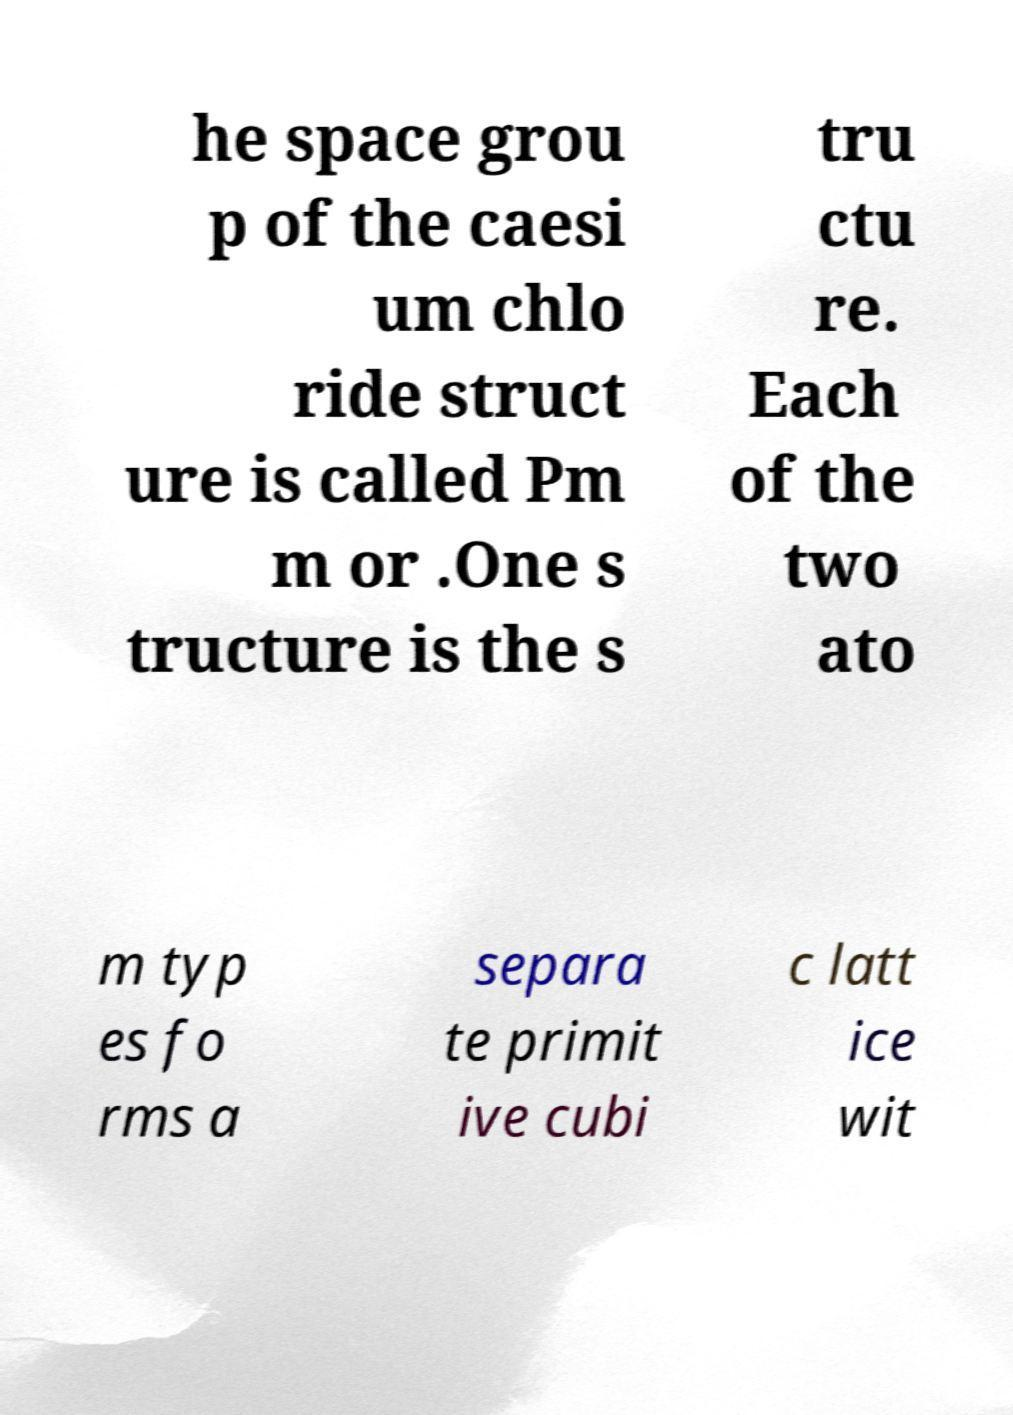Could you assist in decoding the text presented in this image and type it out clearly? he space grou p of the caesi um chlo ride struct ure is called Pm m or .One s tructure is the s tru ctu re. Each of the two ato m typ es fo rms a separa te primit ive cubi c latt ice wit 